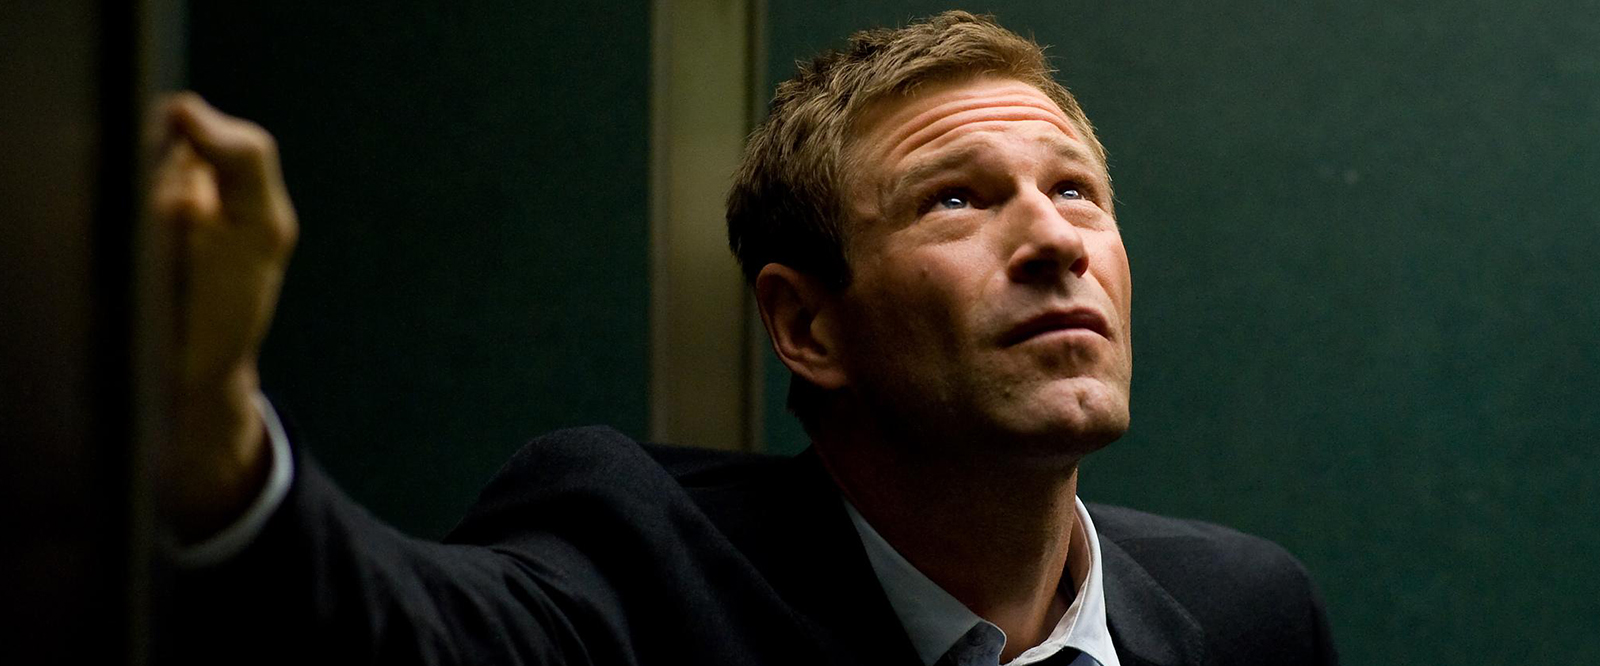How does the lighting in this scene influence the mood of the picture? The lighting is subdued with muted green tones, casting a shadow over the character's face and creating a mysterious and tense atmosphere. Such lighting typically helps convey a sense of uncertainty or suspense, possibly hinting at the complexity or gravity of the scenario being portrayed in the image. 